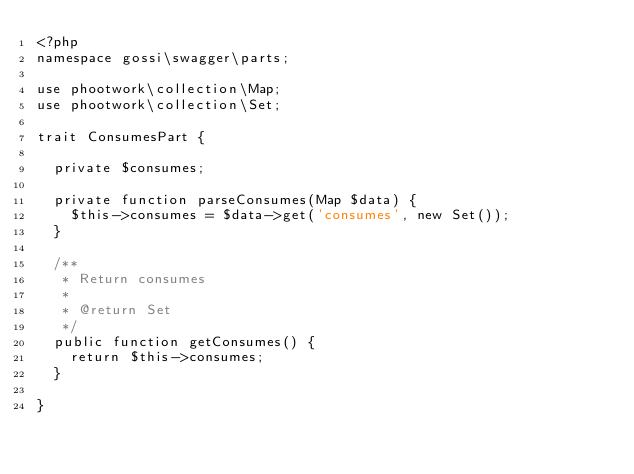<code> <loc_0><loc_0><loc_500><loc_500><_PHP_><?php
namespace gossi\swagger\parts;

use phootwork\collection\Map;
use phootwork\collection\Set;

trait ConsumesPart {

	private $consumes;

	private function parseConsumes(Map $data) {
		$this->consumes = $data->get('consumes', new Set());
	}

	/**
	 * Return consumes
	 *
	 * @return Set
	 */
	public function getConsumes() {
		return $this->consumes;
	}

}
</code> 